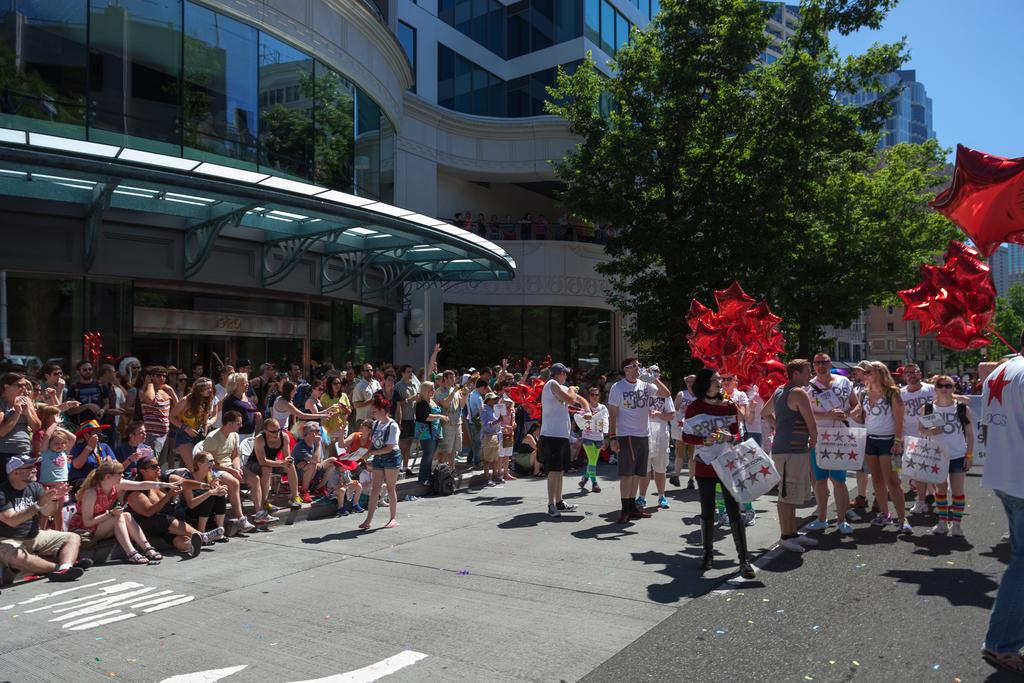What is happening on the road in the image? There are many persons on the road in the image. What can be seen in the background of the image? There are trees, buildings, and the sky visible in the background of the image. What type of oven is being used by the persons on the road in the image? There is no oven present in the image; it features persons on the road and background elements. What type of apparel are the persons wearing in the image? The provided facts do not mention the apparel worn by the persons in the image. 